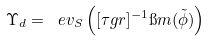<formula> <loc_0><loc_0><loc_500><loc_500>\Upsilon _ { d } = \ e v _ { S } \left ( [ \tau g r ] ^ { - 1 } \i m ( \tilde { \phi } ) \right )</formula> 